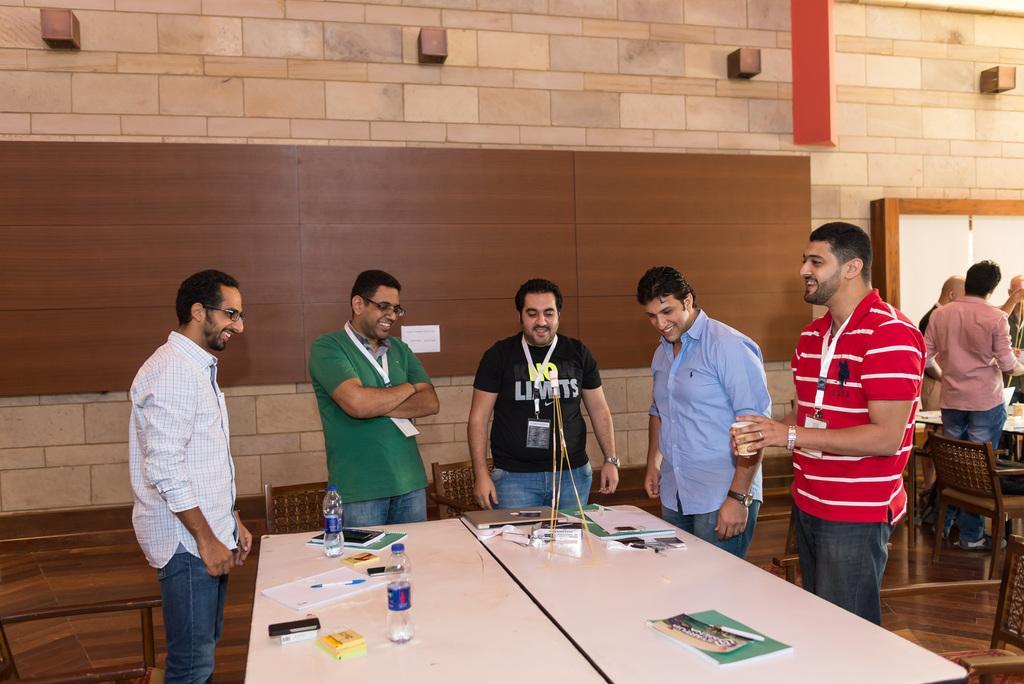Please provide a concise description of this image. In this image I can see few people standing in front of the table. There are some books and bottles on the table. In the background there is a wall. 